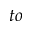<formula> <loc_0><loc_0><loc_500><loc_500>t o</formula> 